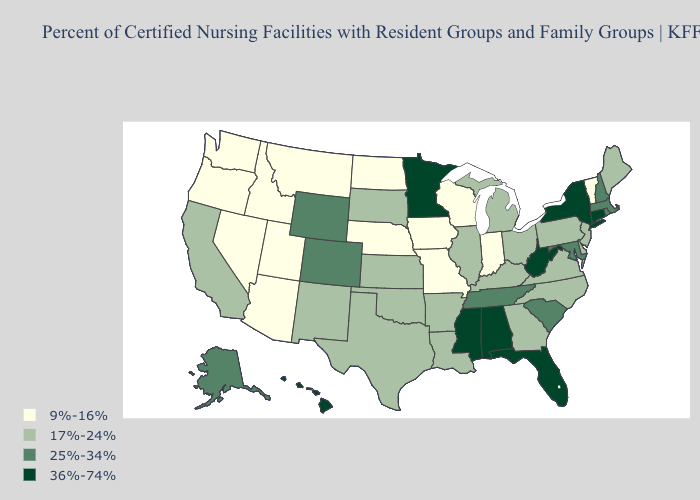Name the states that have a value in the range 36%-74%?
Give a very brief answer. Alabama, Connecticut, Florida, Hawaii, Minnesota, Mississippi, New York, West Virginia. Name the states that have a value in the range 25%-34%?
Answer briefly. Alaska, Colorado, Maryland, Massachusetts, New Hampshire, Rhode Island, South Carolina, Tennessee, Wyoming. Does Oregon have the lowest value in the USA?
Quick response, please. Yes. What is the value of New Hampshire?
Keep it brief. 25%-34%. Does Utah have the lowest value in the USA?
Write a very short answer. Yes. Among the states that border Idaho , does Wyoming have the lowest value?
Be succinct. No. Does Oklahoma have the lowest value in the South?
Quick response, please. Yes. Does Minnesota have the highest value in the MidWest?
Answer briefly. Yes. What is the lowest value in the Northeast?
Answer briefly. 9%-16%. Which states have the lowest value in the USA?
Short answer required. Arizona, Idaho, Indiana, Iowa, Missouri, Montana, Nebraska, Nevada, North Dakota, Oregon, Utah, Vermont, Washington, Wisconsin. Which states hav the highest value in the South?
Quick response, please. Alabama, Florida, Mississippi, West Virginia. Does Alaska have a higher value than New Hampshire?
Answer briefly. No. Which states have the lowest value in the USA?
Short answer required. Arizona, Idaho, Indiana, Iowa, Missouri, Montana, Nebraska, Nevada, North Dakota, Oregon, Utah, Vermont, Washington, Wisconsin. Does Kansas have the lowest value in the MidWest?
Keep it brief. No. Among the states that border Idaho , does Wyoming have the lowest value?
Concise answer only. No. 